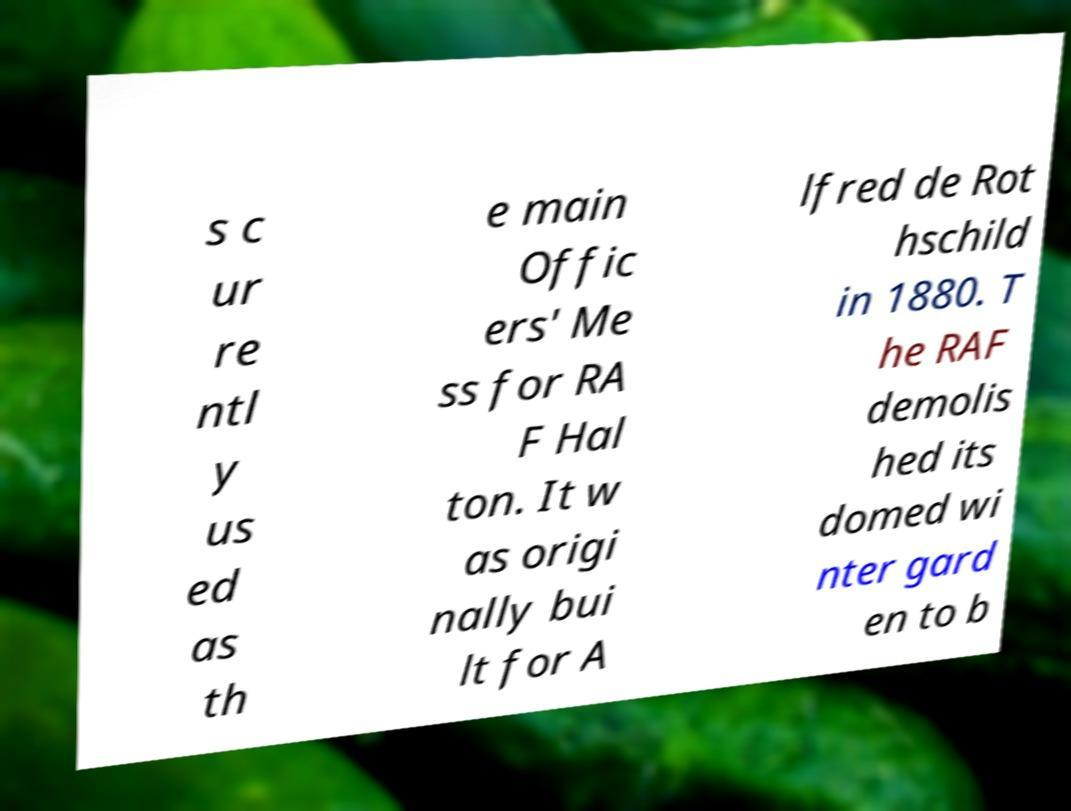Please identify and transcribe the text found in this image. s c ur re ntl y us ed as th e main Offic ers' Me ss for RA F Hal ton. It w as origi nally bui lt for A lfred de Rot hschild in 1880. T he RAF demolis hed its domed wi nter gard en to b 